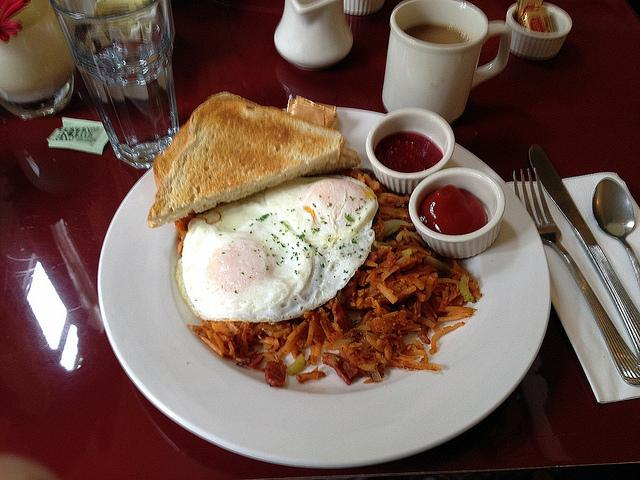What time of day is most likely? Please explain your reasoning. morning. The plate contains foods that are normally served at breakfast in the morning such as eggs and toast. 